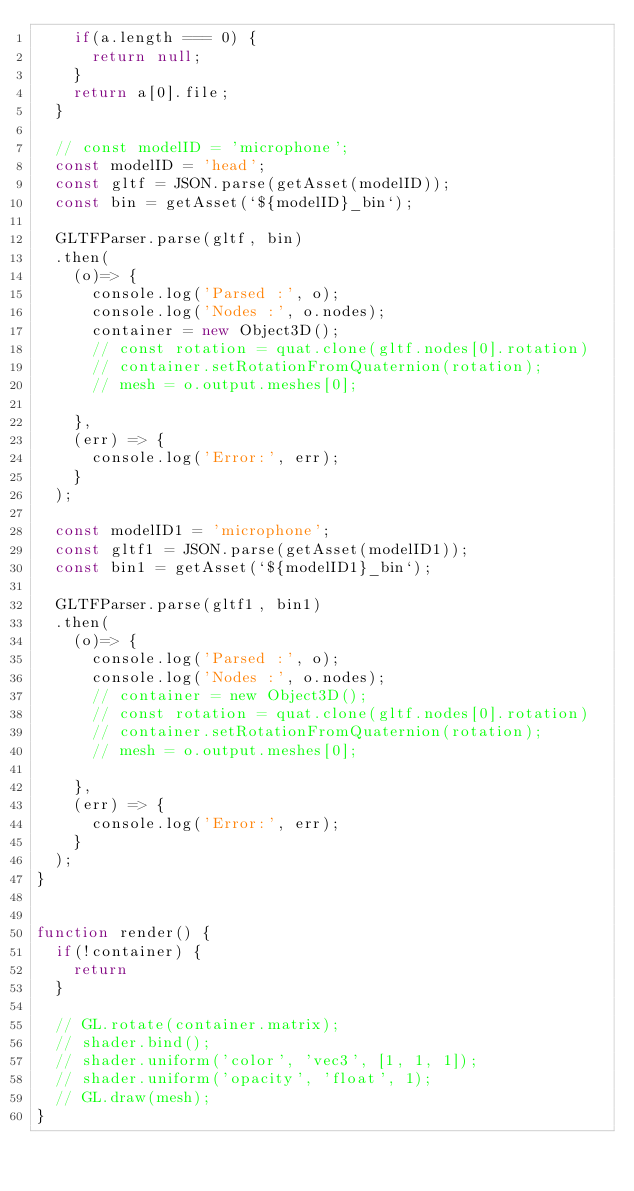Convert code to text. <code><loc_0><loc_0><loc_500><loc_500><_JavaScript_>		if(a.length === 0) {
			return null;
		}
		return a[0].file;
	}

	// const modelID = 'microphone';
	const modelID = 'head';
	const gltf = JSON.parse(getAsset(modelID));
	const bin = getAsset(`${modelID}_bin`);

	GLTFParser.parse(gltf, bin)
	.then(
		(o)=> {
			console.log('Parsed :', o);
			console.log('Nodes :', o.nodes);
			container = new Object3D();
			// const rotation = quat.clone(gltf.nodes[0].rotation)
			// container.setRotationFromQuaternion(rotation);
			// mesh = o.output.meshes[0];
			
		}, 
		(err) => {
			console.log('Error:', err);
		}
	);

	const modelID1 = 'microphone';
	const gltf1 = JSON.parse(getAsset(modelID1));
	const bin1 = getAsset(`${modelID1}_bin`);

	GLTFParser.parse(gltf1, bin1)
	.then(
		(o)=> {
			console.log('Parsed :', o);
			console.log('Nodes :', o.nodes);
			// container = new Object3D();
			// const rotation = quat.clone(gltf.nodes[0].rotation)
			// container.setRotationFromQuaternion(rotation);
			// mesh = o.output.meshes[0];
			
		}, 
		(err) => {
			console.log('Error:', err);
		}
	);
}


function render() {
	if(!container) {
		return
	}

	// GL.rotate(container.matrix);
	// shader.bind();
	// shader.uniform('color', 'vec3', [1, 1, 1]);
	// shader.uniform('opacity', 'float', 1);
	// GL.draw(mesh);
}
</code> 